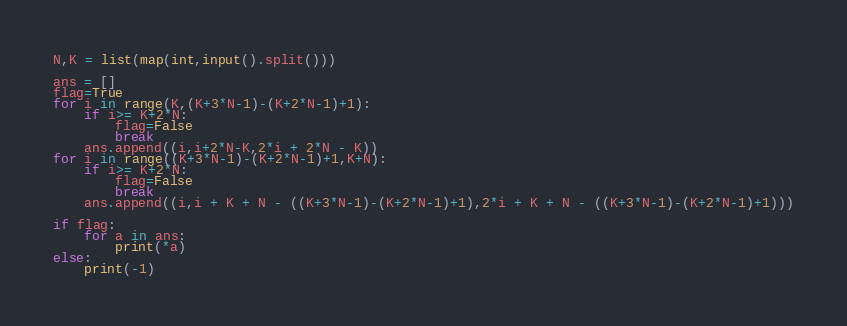Convert code to text. <code><loc_0><loc_0><loc_500><loc_500><_Python_>N,K = list(map(int,input().split()))

ans = []
flag=True
for i in range(K,(K+3*N-1)-(K+2*N-1)+1):
    if i>= K+2*N:
        flag=False
        break
    ans.append((i,i+2*N-K,2*i + 2*N - K))
for i in range((K+3*N-1)-(K+2*N-1)+1,K+N):
    if i>= K+2*N:
        flag=False
        break
    ans.append((i,i + K + N - ((K+3*N-1)-(K+2*N-1)+1),2*i + K + N - ((K+3*N-1)-(K+2*N-1)+1)))

if flag:
    for a in ans:
        print(*a)
else:
    print(-1)</code> 